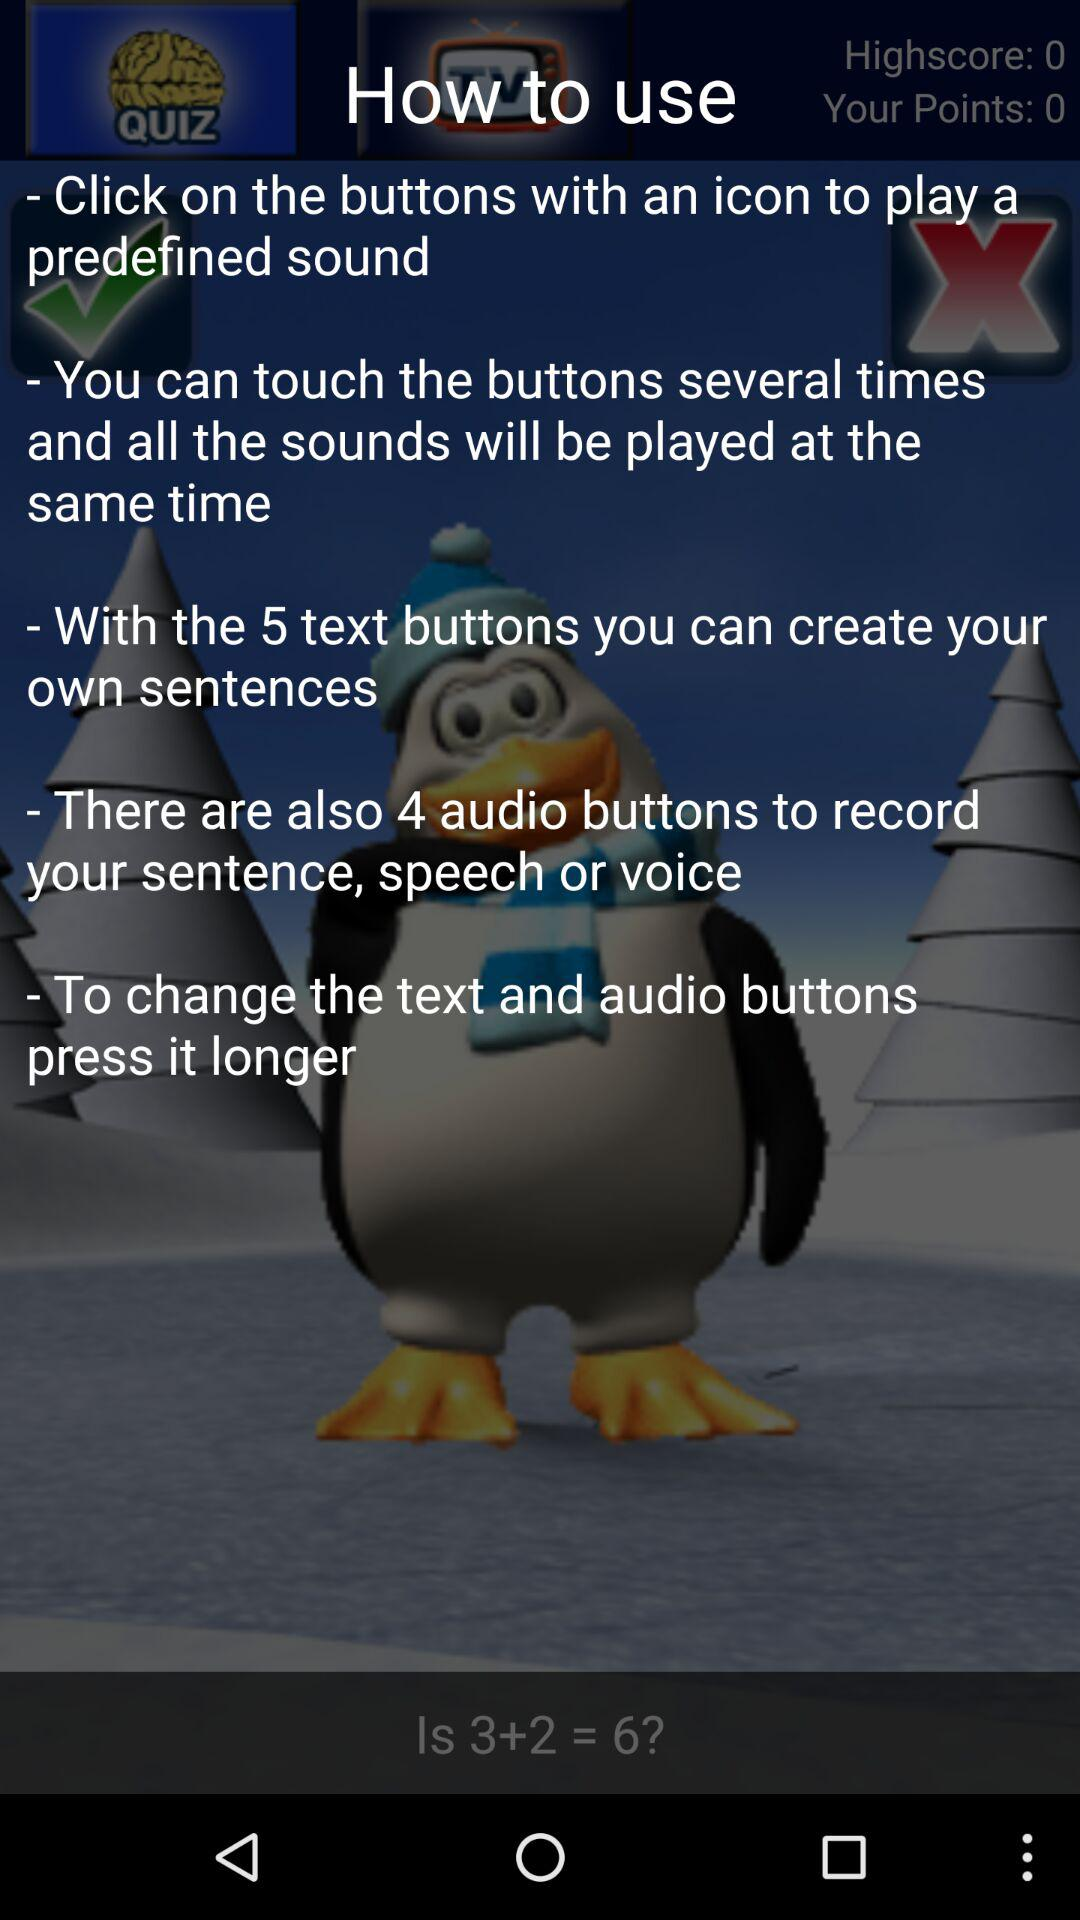What's the number of audio buttons to record a sentence? The number of audio buttons is 4. 